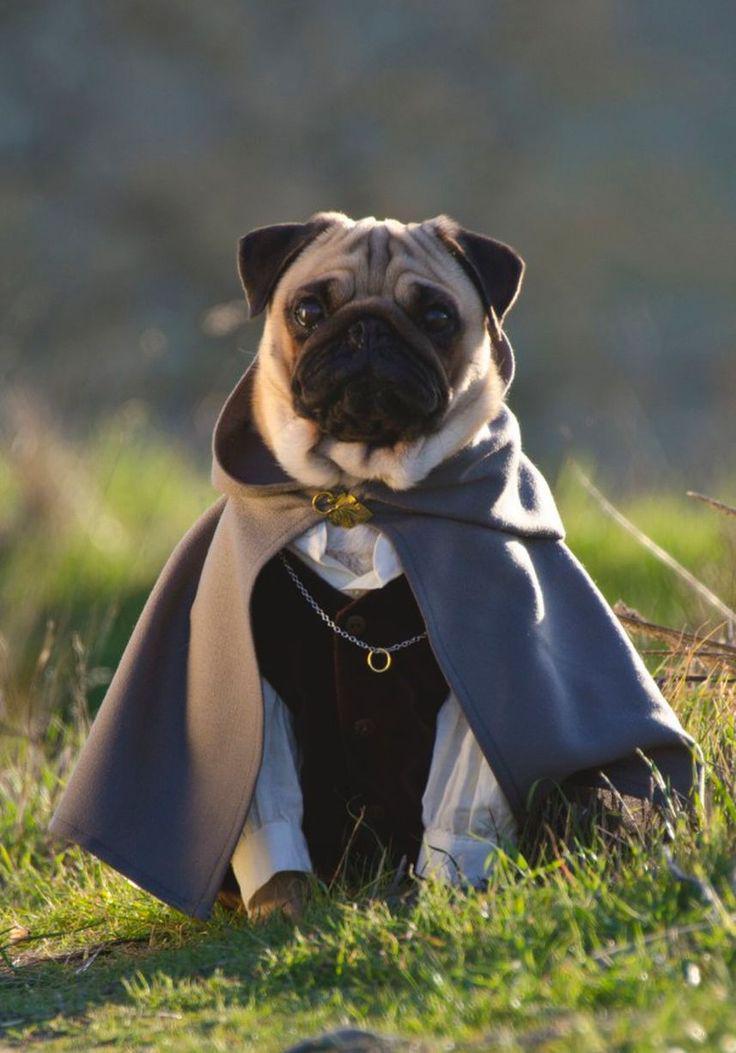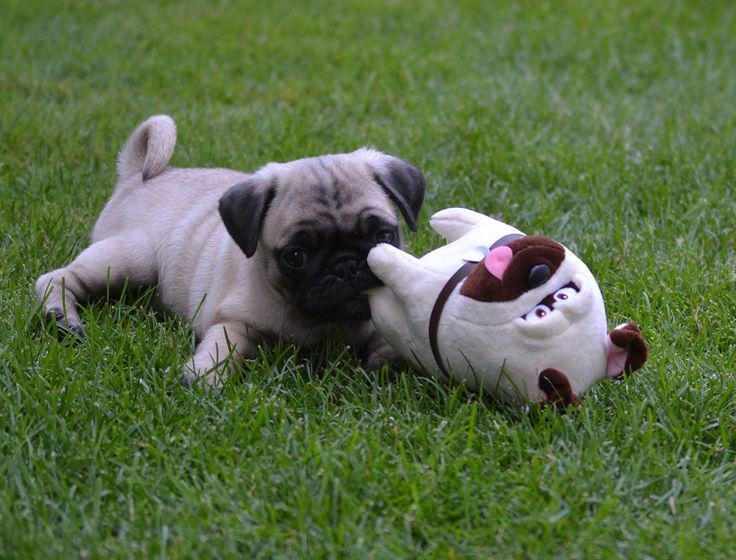The first image is the image on the left, the second image is the image on the right. For the images displayed, is the sentence "A dog is running." factually correct? Answer yes or no. No. The first image is the image on the left, the second image is the image on the right. For the images displayed, is the sentence "The right image contains at least three dogs." factually correct? Answer yes or no. No. 